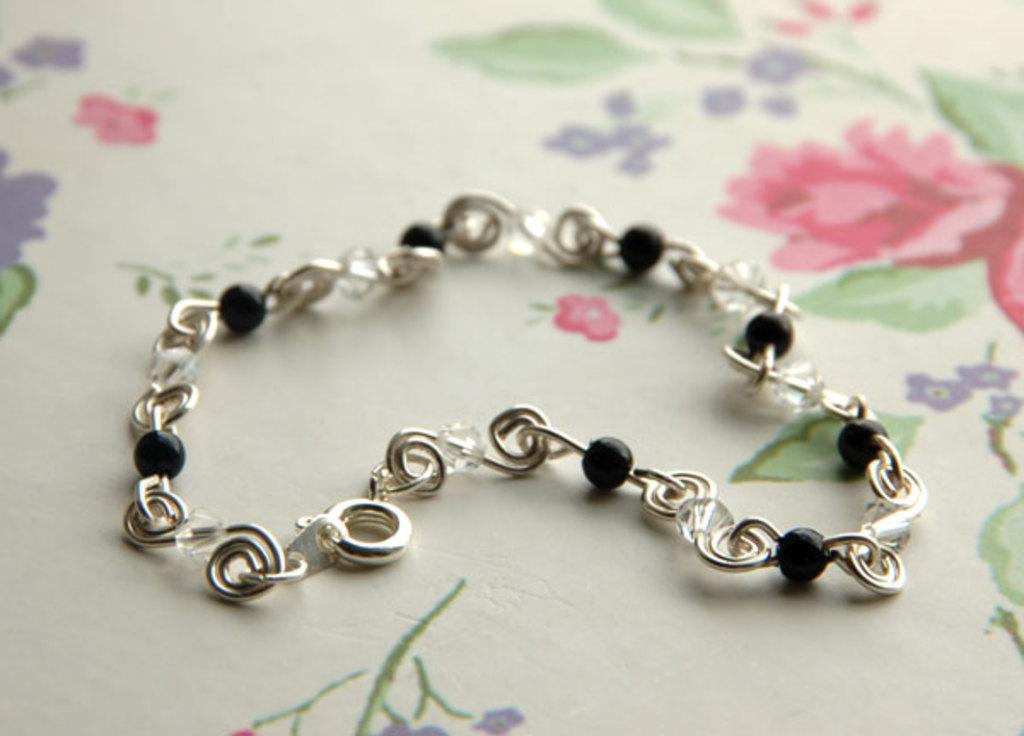What material is the chain made of? The chain is made of stainless steel. What color are the balls on the chain? The balls on the chain are black in color. What type of flag is visible in the image? There is no flag present in the image. What is located on the back of the chain? The image does not show the back of the chain, so it cannot be determined what might be located there. 